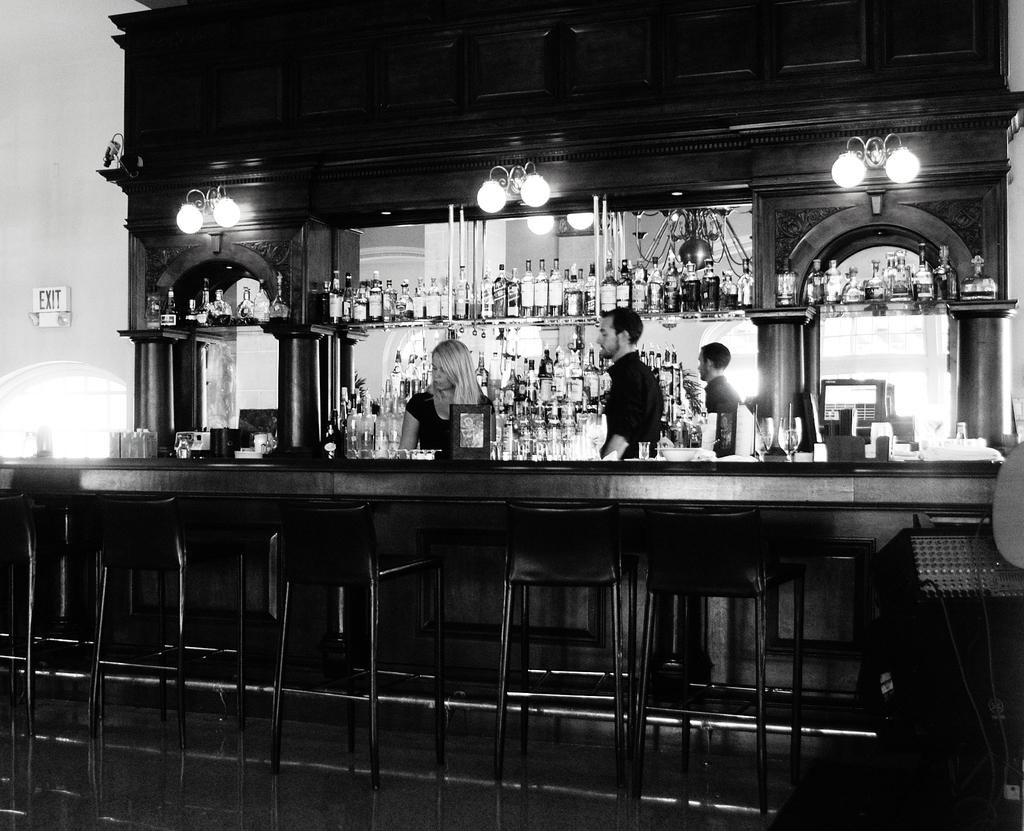What is the color scheme of the image? The image is black and white. How many people are in the image? There is a woman and a man in the image. What objects can be seen in the image besides the people? There are bottles and lights in the image. What type of bell can be heard ringing in the image? There is no bell present in the image, and therefore no sound can be heard. 